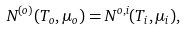<formula> <loc_0><loc_0><loc_500><loc_500>N ^ { ( o ) } ( T _ { o } , \mu _ { o } ) = N ^ { o , i } ( T _ { i } , \mu _ { i } ) ,</formula> 